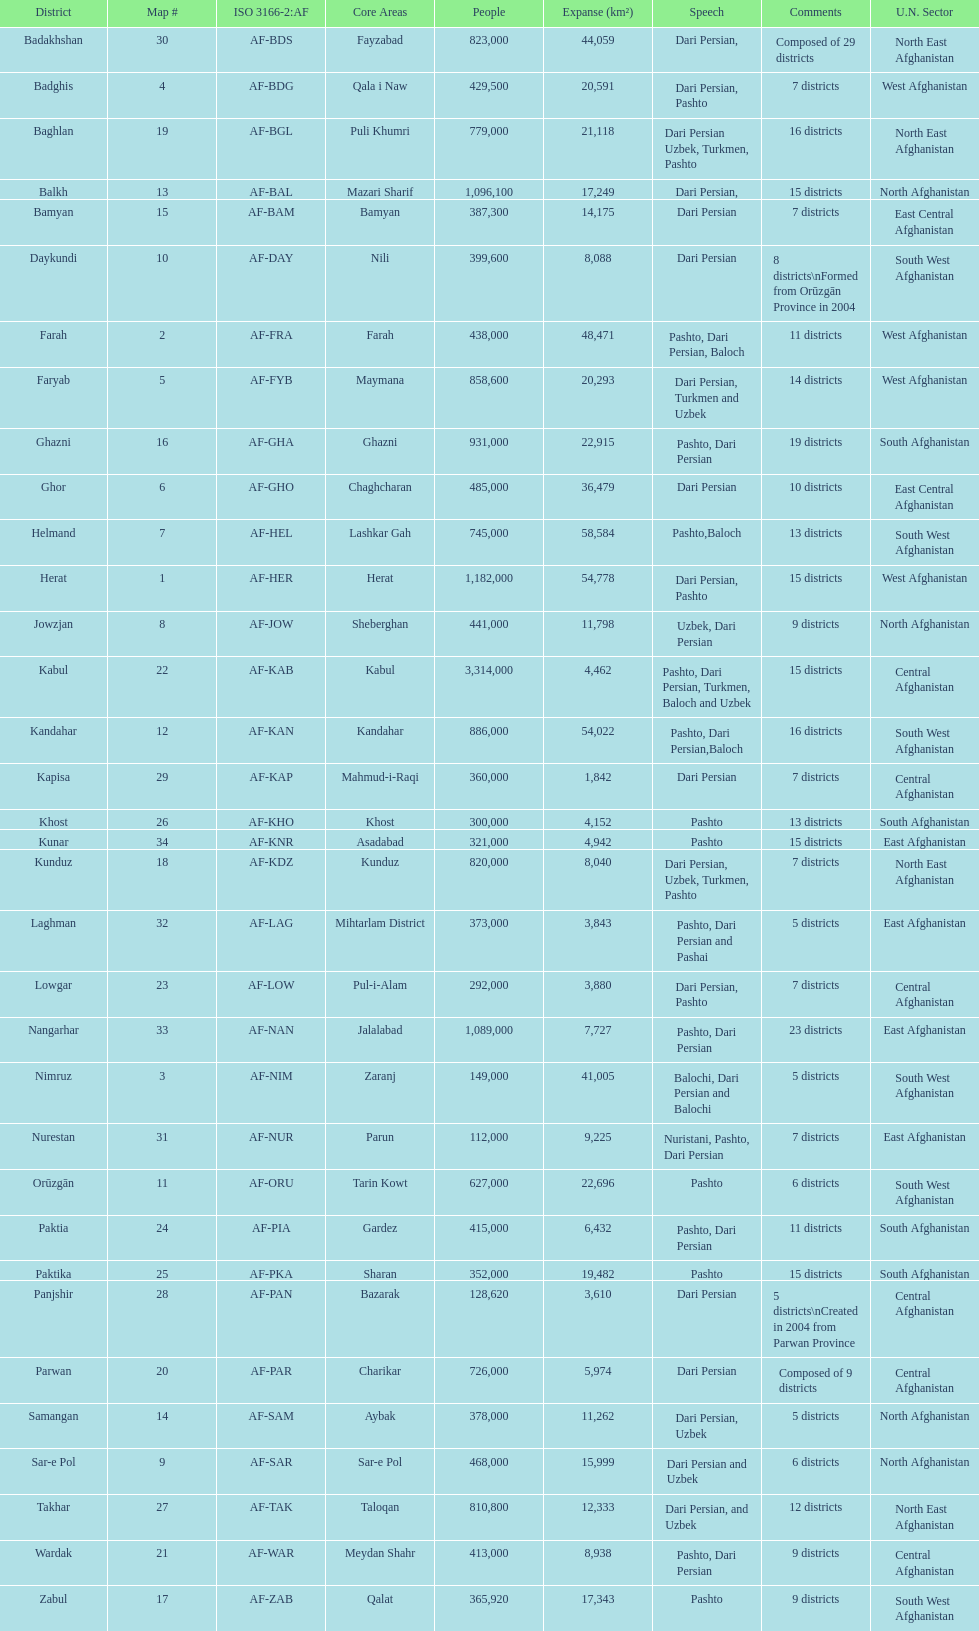Herat has a population of 1,182,000, can you list their languages Dari Persian, Pashto. 